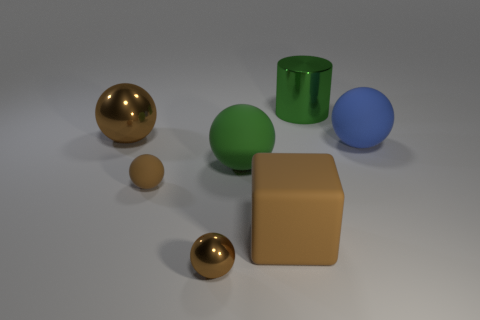How many brown spheres must be subtracted to get 1 brown spheres? 2 Subtract all yellow blocks. How many brown spheres are left? 3 Subtract all blue balls. How many balls are left? 4 Subtract all green balls. How many balls are left? 4 Subtract all red spheres. Subtract all gray cubes. How many spheres are left? 5 Add 3 green cylinders. How many objects exist? 10 Subtract all blocks. How many objects are left? 6 Subtract 0 blue cylinders. How many objects are left? 7 Subtract all spheres. Subtract all large rubber cubes. How many objects are left? 1 Add 5 big matte balls. How many big matte balls are left? 7 